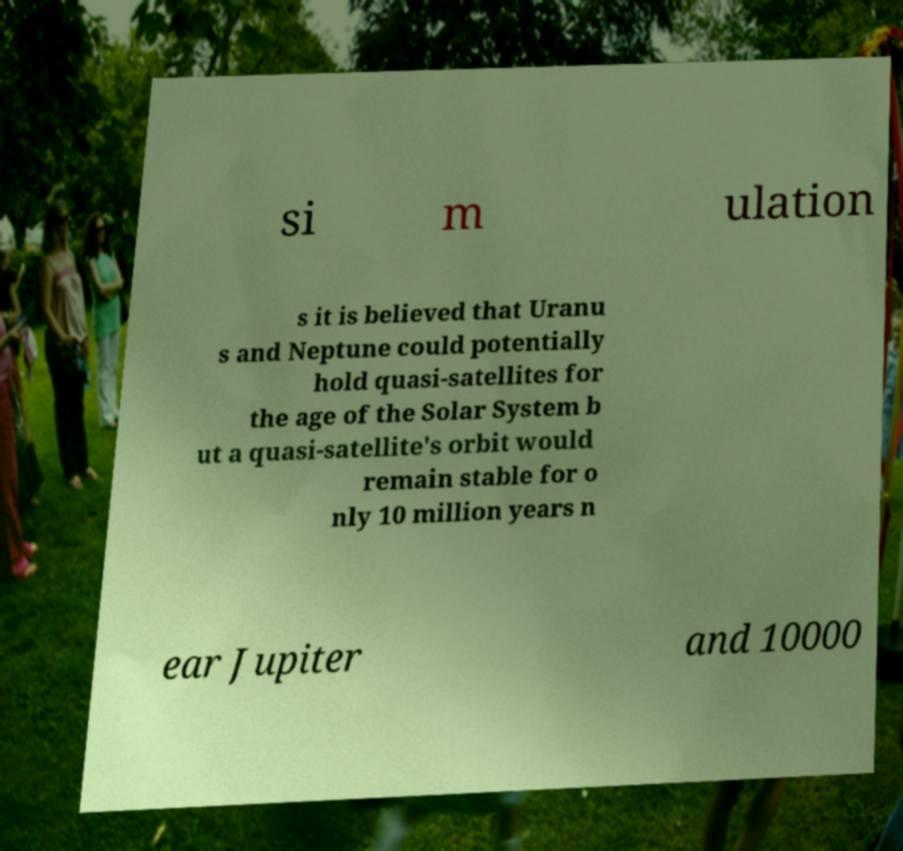Can you read and provide the text displayed in the image?This photo seems to have some interesting text. Can you extract and type it out for me? si m ulation s it is believed that Uranu s and Neptune could potentially hold quasi-satellites for the age of the Solar System b ut a quasi-satellite's orbit would remain stable for o nly 10 million years n ear Jupiter and 10000 